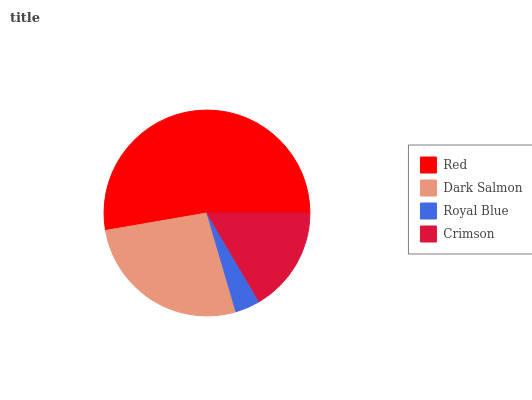Is Royal Blue the minimum?
Answer yes or no. Yes. Is Red the maximum?
Answer yes or no. Yes. Is Dark Salmon the minimum?
Answer yes or no. No. Is Dark Salmon the maximum?
Answer yes or no. No. Is Red greater than Dark Salmon?
Answer yes or no. Yes. Is Dark Salmon less than Red?
Answer yes or no. Yes. Is Dark Salmon greater than Red?
Answer yes or no. No. Is Red less than Dark Salmon?
Answer yes or no. No. Is Dark Salmon the high median?
Answer yes or no. Yes. Is Crimson the low median?
Answer yes or no. Yes. Is Crimson the high median?
Answer yes or no. No. Is Royal Blue the low median?
Answer yes or no. No. 